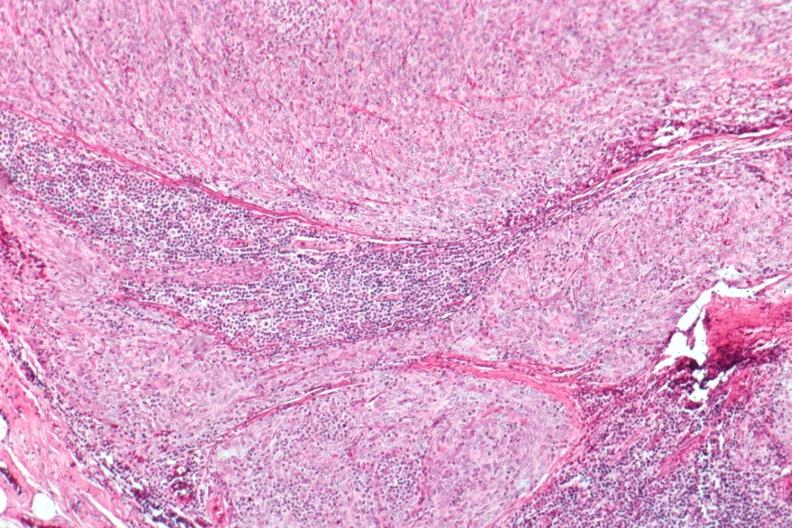what is present?
Answer the question using a single word or phrase. Thymoma 